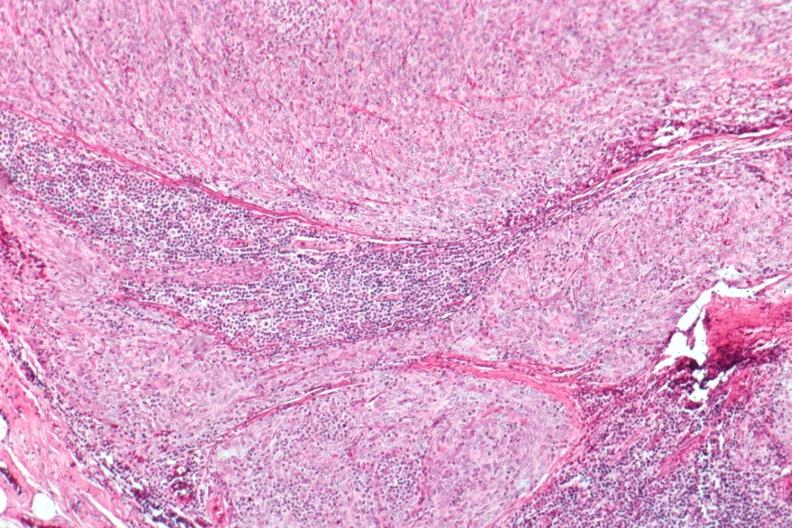what is present?
Answer the question using a single word or phrase. Thymoma 